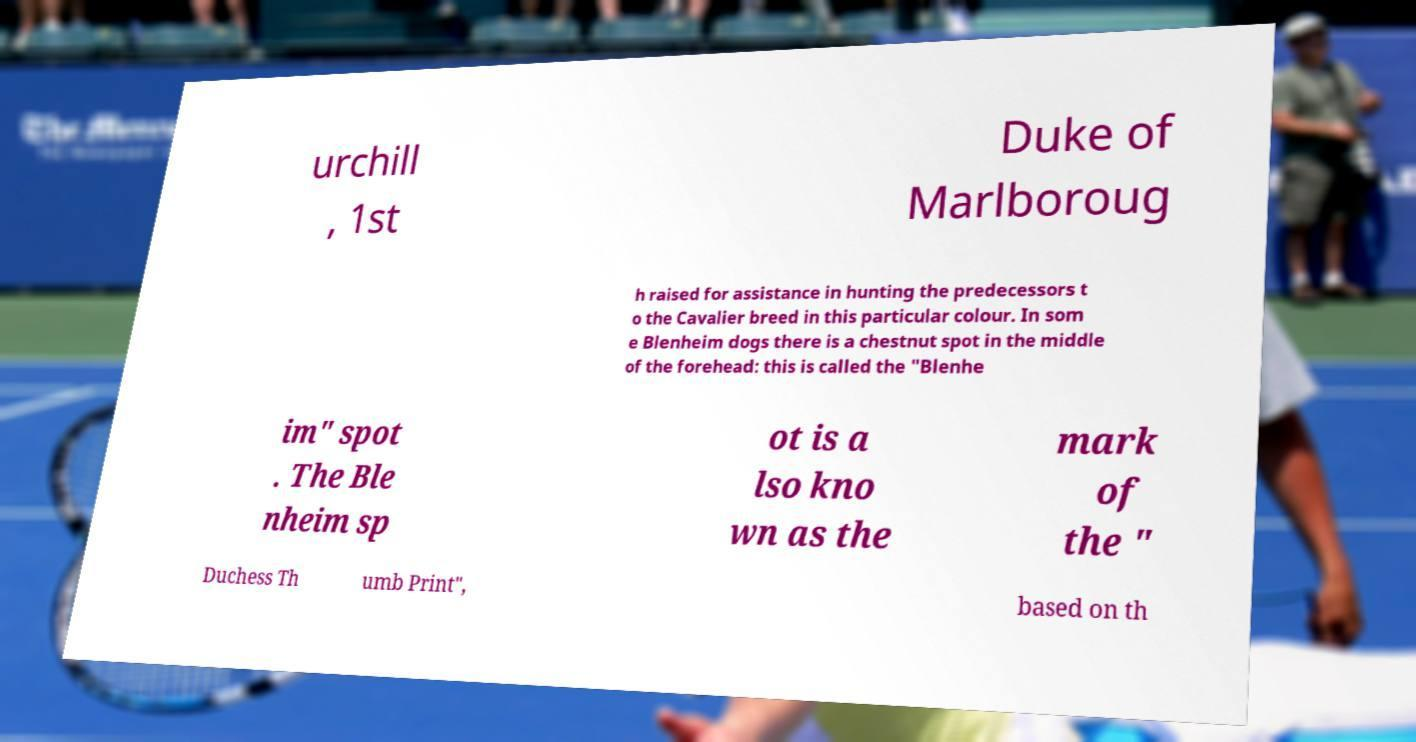Could you extract and type out the text from this image? urchill , 1st Duke of Marlboroug h raised for assistance in hunting the predecessors t o the Cavalier breed in this particular colour. In som e Blenheim dogs there is a chestnut spot in the middle of the forehead: this is called the "Blenhe im" spot . The Ble nheim sp ot is a lso kno wn as the mark of the " Duchess Th umb Print", based on th 